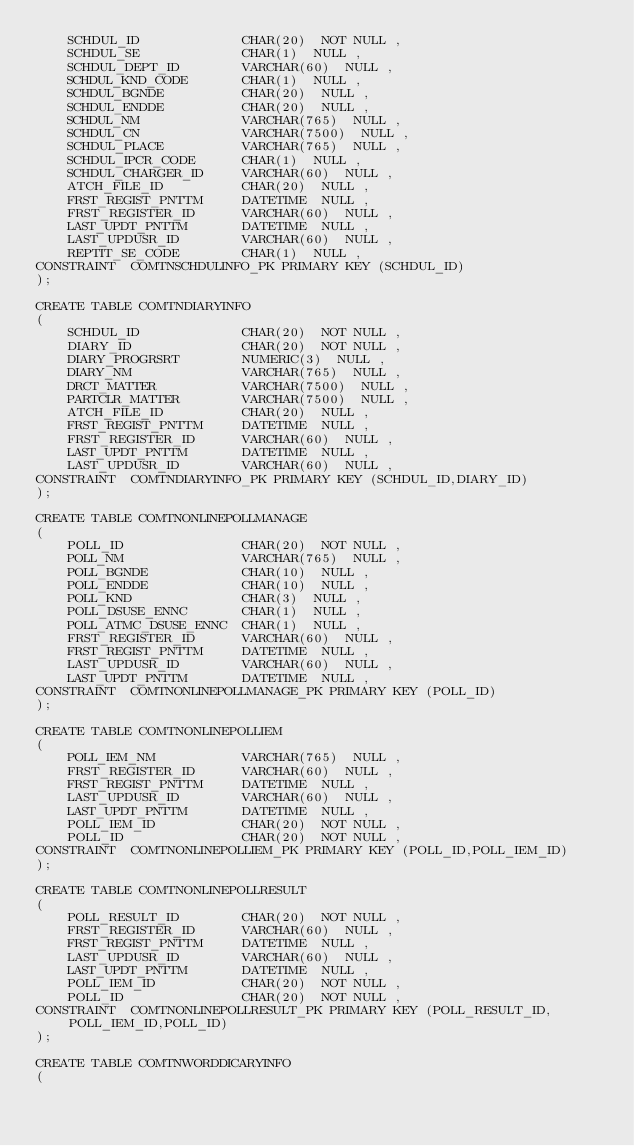Convert code to text. <code><loc_0><loc_0><loc_500><loc_500><_SQL_>	SCHDUL_ID             CHAR(20)  NOT NULL ,
	SCHDUL_SE             CHAR(1)  NULL ,
	SCHDUL_DEPT_ID        VARCHAR(60)  NULL ,
	SCHDUL_KND_CODE       CHAR(1)  NULL ,
	SCHDUL_BGNDE          CHAR(20)  NULL ,
	SCHDUL_ENDDE          CHAR(20)  NULL ,
	SCHDUL_NM             VARCHAR(765)  NULL ,
	SCHDUL_CN             VARCHAR(7500)  NULL ,
	SCHDUL_PLACE          VARCHAR(765)  NULL ,
	SCHDUL_IPCR_CODE      CHAR(1)  NULL ,
	SCHDUL_CHARGER_ID     VARCHAR(60)  NULL ,
	ATCH_FILE_ID          CHAR(20)  NULL ,
	FRST_REGIST_PNTTM     DATETIME  NULL ,
	FRST_REGISTER_ID      VARCHAR(60)  NULL ,
	LAST_UPDT_PNTTM       DATETIME  NULL ,
	LAST_UPDUSR_ID        VARCHAR(60)  NULL ,
	REPTIT_SE_CODE        CHAR(1)  NULL ,
CONSTRAINT  COMTNSCHDULINFO_PK PRIMARY KEY (SCHDUL_ID)
);

CREATE TABLE COMTNDIARYINFO
(
	SCHDUL_ID             CHAR(20)  NOT NULL ,
	DIARY_ID              CHAR(20)  NOT NULL ,
	DIARY_PROGRSRT        NUMERIC(3)  NULL ,
	DIARY_NM              VARCHAR(765)  NULL ,
	DRCT_MATTER           VARCHAR(7500)  NULL ,
	PARTCLR_MATTER        VARCHAR(7500)  NULL ,
	ATCH_FILE_ID          CHAR(20)  NULL ,
	FRST_REGIST_PNTTM     DATETIME  NULL ,
	FRST_REGISTER_ID      VARCHAR(60)  NULL ,
	LAST_UPDT_PNTTM       DATETIME  NULL ,
	LAST_UPDUSR_ID        VARCHAR(60)  NULL ,
CONSTRAINT  COMTNDIARYINFO_PK PRIMARY KEY (SCHDUL_ID,DIARY_ID)
);

CREATE TABLE COMTNONLINEPOLLMANAGE
(
	POLL_ID               CHAR(20)  NOT NULL ,
	POLL_NM               VARCHAR(765)  NULL ,
	POLL_BGNDE            CHAR(10)  NULL ,
	POLL_ENDDE            CHAR(10)  NULL ,
	POLL_KND              CHAR(3)  NULL ,
	POLL_DSUSE_ENNC       CHAR(1)  NULL ,
	POLL_ATMC_DSUSE_ENNC  CHAR(1)  NULL ,
	FRST_REGISTER_ID      VARCHAR(60)  NULL ,
	FRST_REGIST_PNTTM     DATETIME  NULL ,
	LAST_UPDUSR_ID        VARCHAR(60)  NULL ,
	LAST_UPDT_PNTTM       DATETIME  NULL ,
CONSTRAINT  COMTNONLINEPOLLMANAGE_PK PRIMARY KEY (POLL_ID)
);

CREATE TABLE COMTNONLINEPOLLIEM
(
	POLL_IEM_NM           VARCHAR(765)  NULL ,
	FRST_REGISTER_ID      VARCHAR(60)  NULL ,
	FRST_REGIST_PNTTM     DATETIME  NULL ,
	LAST_UPDUSR_ID        VARCHAR(60)  NULL ,
	LAST_UPDT_PNTTM       DATETIME  NULL ,
	POLL_IEM_ID           CHAR(20)  NOT NULL ,
	POLL_ID               CHAR(20)  NOT NULL ,
CONSTRAINT  COMTNONLINEPOLLIEM_PK PRIMARY KEY (POLL_ID,POLL_IEM_ID)
);

CREATE TABLE COMTNONLINEPOLLRESULT
(
	POLL_RESULT_ID        CHAR(20)  NOT NULL ,
	FRST_REGISTER_ID      VARCHAR(60)  NULL ,
	FRST_REGIST_PNTTM     DATETIME  NULL ,
	LAST_UPDUSR_ID        VARCHAR(60)  NULL ,
	LAST_UPDT_PNTTM       DATETIME  NULL ,
	POLL_IEM_ID           CHAR(20)  NOT NULL ,
	POLL_ID               CHAR(20)  NOT NULL ,
CONSTRAINT  COMTNONLINEPOLLRESULT_PK PRIMARY KEY (POLL_RESULT_ID,POLL_IEM_ID,POLL_ID)
);

CREATE TABLE COMTNWORDDICARYINFO
(</code> 